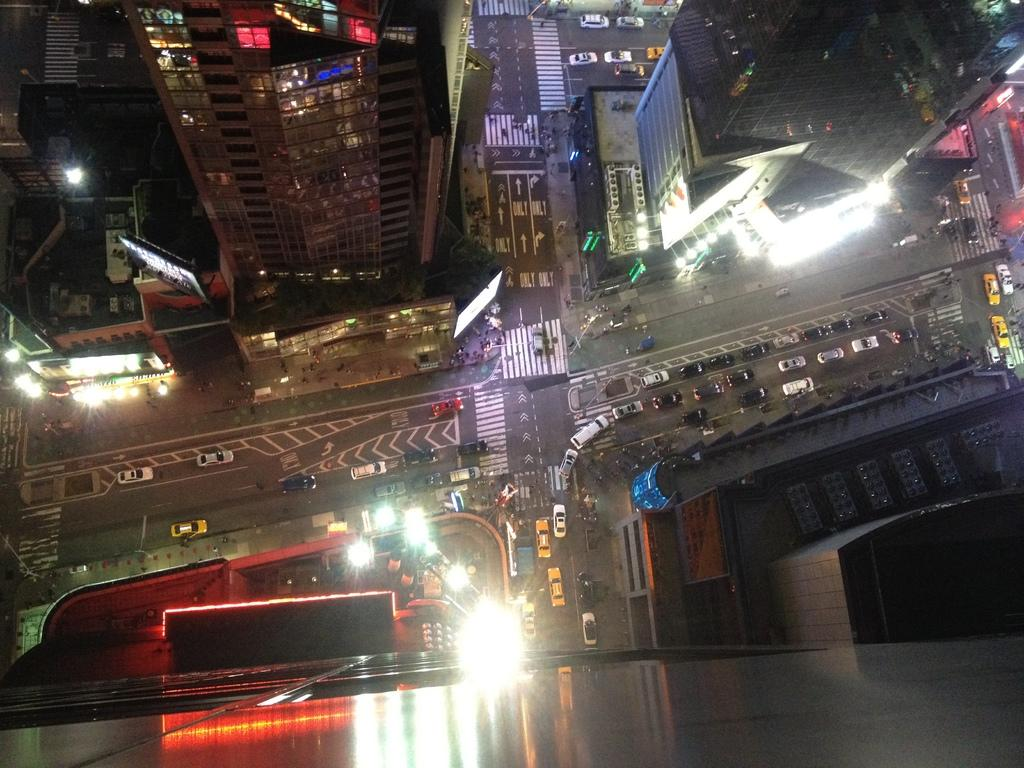What type of buildings can be seen in the image? There are skyscrapers in the image. What can be seen illuminated in the image? Lights are visible in the image. What objects are present in the image that might be used for displaying information or advertisements? Boards are present in the image. What type of transportation is visible in the image? Vehicles are visible in the image. What safety feature is present on the road in the image? Zebra crossings are on the road in the image. At what time of day was the image taken? The image was taken during night time. How many minutes does it take for the zipper to open in the image? There is no zipper present in the image. What type of bird is nesting in the image? There is no bird or nest present in the image. 